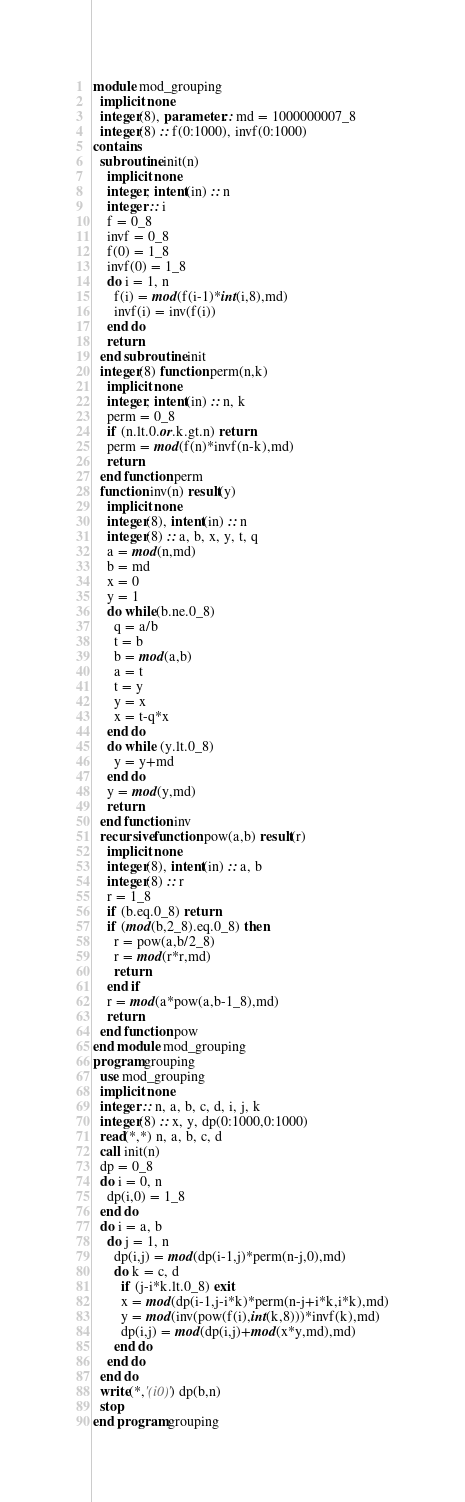<code> <loc_0><loc_0><loc_500><loc_500><_FORTRAN_>module mod_grouping
  implicit none
  integer(8), parameter :: md = 1000000007_8
  integer(8) :: f(0:1000), invf(0:1000)
contains
  subroutine init(n)
    implicit none
    integer, intent(in) :: n
    integer :: i
    f = 0_8
    invf = 0_8
    f(0) = 1_8
    invf(0) = 1_8
    do i = 1, n
      f(i) = mod(f(i-1)*int(i,8),md)
      invf(i) = inv(f(i))
    end do
    return
  end subroutine init
  integer(8) function perm(n,k)
    implicit none
    integer, intent(in) :: n, k
    perm = 0_8
    if (n.lt.0.or.k.gt.n) return
    perm = mod(f(n)*invf(n-k),md)
    return
  end function perm
  function inv(n) result(y)
    implicit none
    integer(8), intent(in) :: n
    integer(8) :: a, b, x, y, t, q
    a = mod(n,md)
    b = md
    x = 0
    y = 1
    do while(b.ne.0_8)
      q = a/b
      t = b
      b = mod(a,b)
      a = t
      t = y
      y = x
      x = t-q*x
    end do
    do while (y.lt.0_8)
      y = y+md
    end do
    y = mod(y,md)
    return
  end function inv
  recursive function pow(a,b) result(r)
    implicit none
    integer(8), intent(in) :: a, b
    integer(8) :: r
    r = 1_8
    if (b.eq.0_8) return
    if (mod(b,2_8).eq.0_8) then
      r = pow(a,b/2_8)
      r = mod(r*r,md)
      return
    end if
    r = mod(a*pow(a,b-1_8),md)
    return
  end function pow
end module mod_grouping
program grouping
  use mod_grouping
  implicit none
  integer :: n, a, b, c, d, i, j, k
  integer(8) :: x, y, dp(0:1000,0:1000)
  read(*,*) n, a, b, c, d
  call init(n)
  dp = 0_8
  do i = 0, n
    dp(i,0) = 1_8
  end do
  do i = a, b
    do j = 1, n
      dp(i,j) = mod(dp(i-1,j)*perm(n-j,0),md)
      do k = c, d
        if (j-i*k.lt.0_8) exit
        x = mod(dp(i-1,j-i*k)*perm(n-j+i*k,i*k),md)
        y = mod(inv(pow(f(i),int(k,8)))*invf(k),md)
        dp(i,j) = mod(dp(i,j)+mod(x*y,md),md)
      end do
    end do
  end do
  write(*,'(i0)') dp(b,n)
  stop
end program grouping</code> 